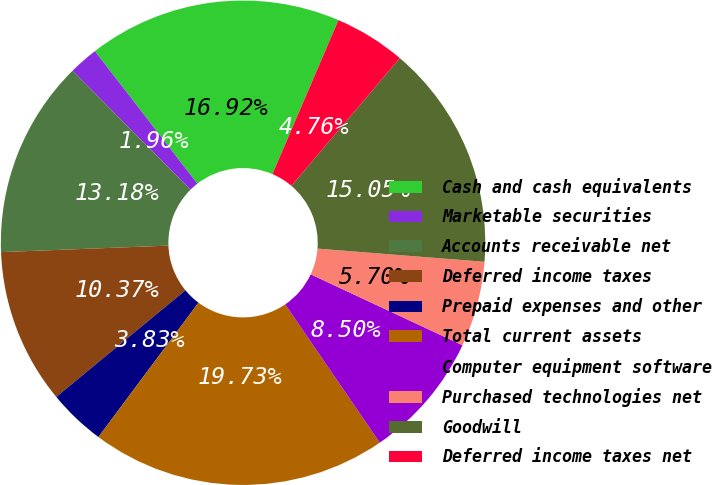<chart> <loc_0><loc_0><loc_500><loc_500><pie_chart><fcel>Cash and cash equivalents<fcel>Marketable securities<fcel>Accounts receivable net<fcel>Deferred income taxes<fcel>Prepaid expenses and other<fcel>Total current assets<fcel>Computer equipment software<fcel>Purchased technologies net<fcel>Goodwill<fcel>Deferred income taxes net<nl><fcel>16.92%<fcel>1.96%<fcel>13.18%<fcel>10.37%<fcel>3.83%<fcel>19.73%<fcel>8.5%<fcel>5.7%<fcel>15.05%<fcel>4.76%<nl></chart> 